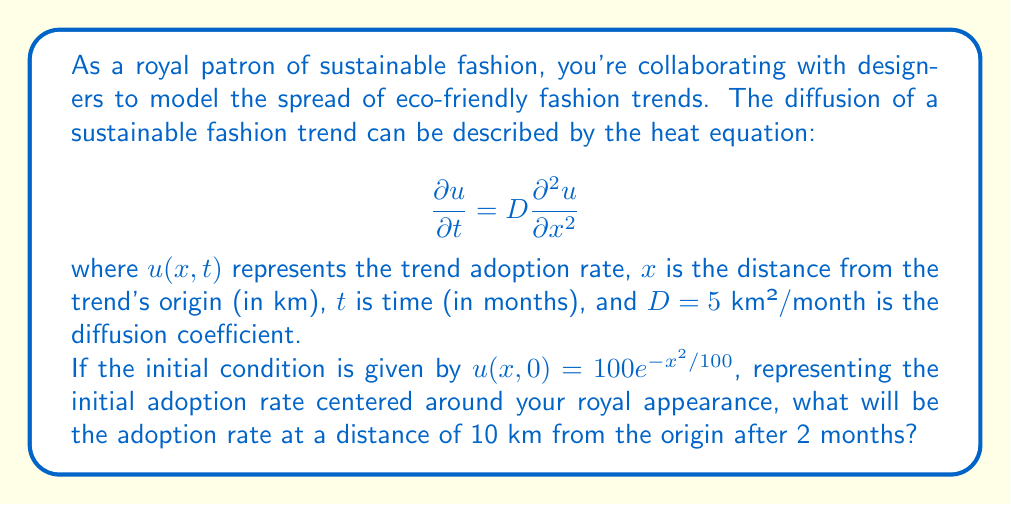Can you solve this math problem? To solve this problem, we need to use the fundamental solution of the heat equation, which is:

$$u(x,t) = \frac{1}{\sqrt{4\pi Dt}} \int_{-\infty}^{\infty} u(\xi,0) e^{-\frac{(x-\xi)^2}{4Dt}} d\xi$$

Given:
- Initial condition: $u(x,0) = 100e^{-x^2/100}$
- Diffusion coefficient: $D = 5$ km²/month
- Time: $t = 2$ months
- Distance: $x = 10$ km

Step 1: Substitute the given values into the fundamental solution:

$$u(10,2) = \frac{1}{\sqrt{4\pi (5)(2)}} \int_{-\infty}^{\infty} 100e^{-\xi^2/100} e^{-\frac{(10-\xi)^2}{4(5)(2)}} d\xi$$

Step 2: Simplify the constants:

$$u(10,2) = \frac{100}{\sqrt{40\pi}} \int_{-\infty}^{\infty} e^{-\xi^2/100} e^{-\frac{(10-\xi)^2}{40}} d\xi$$

Step 3: Combine the exponents:

$$u(10,2) = \frac{100}{\sqrt{40\pi}} \int_{-\infty}^{\infty} e^{-\frac{\xi^2}{100} - \frac{100-20\xi+\xi^2}{40}} d\xi$$

$$u(10,2) = \frac{100}{\sqrt{40\pi}} \int_{-\infty}^{\infty} e^{-\frac{7\xi^2}{200} + \frac{\xi}{2} - \frac{5}{2}} d\xi$$

Step 4: Complete the square in the exponent:

$$u(10,2) = \frac{100}{\sqrt{40\pi}} e^{-\frac{5}{2}} \int_{-\infty}^{\infty} e^{-\frac{7}{200}(\xi^2 - \frac{100}{7}\xi + \frac{2500}{49})} d\xi$$

Step 5: Use the Gaussian integral formula:

$$\int_{-\infty}^{\infty} e^{-ax^2} dx = \sqrt{\frac{\pi}{a}}$$

Applying this to our integral with $a = \frac{7}{200}$:

$$u(10,2) = \frac{100}{\sqrt{40\pi}} e^{-\frac{5}{2}} \sqrt{\frac{200\pi}{7}} e^{\frac{2500}{686}}$$

Step 6: Simplify:

$$u(10,2) = 100 \sqrt{\frac{5}{7}} e^{-\frac{5}{2}} e^{\frac{2500}{686}} \approx 52.62$$
Answer: The adoption rate of the sustainable fashion trend at a distance of 10 km from the origin after 2 months will be approximately 52.62%. 